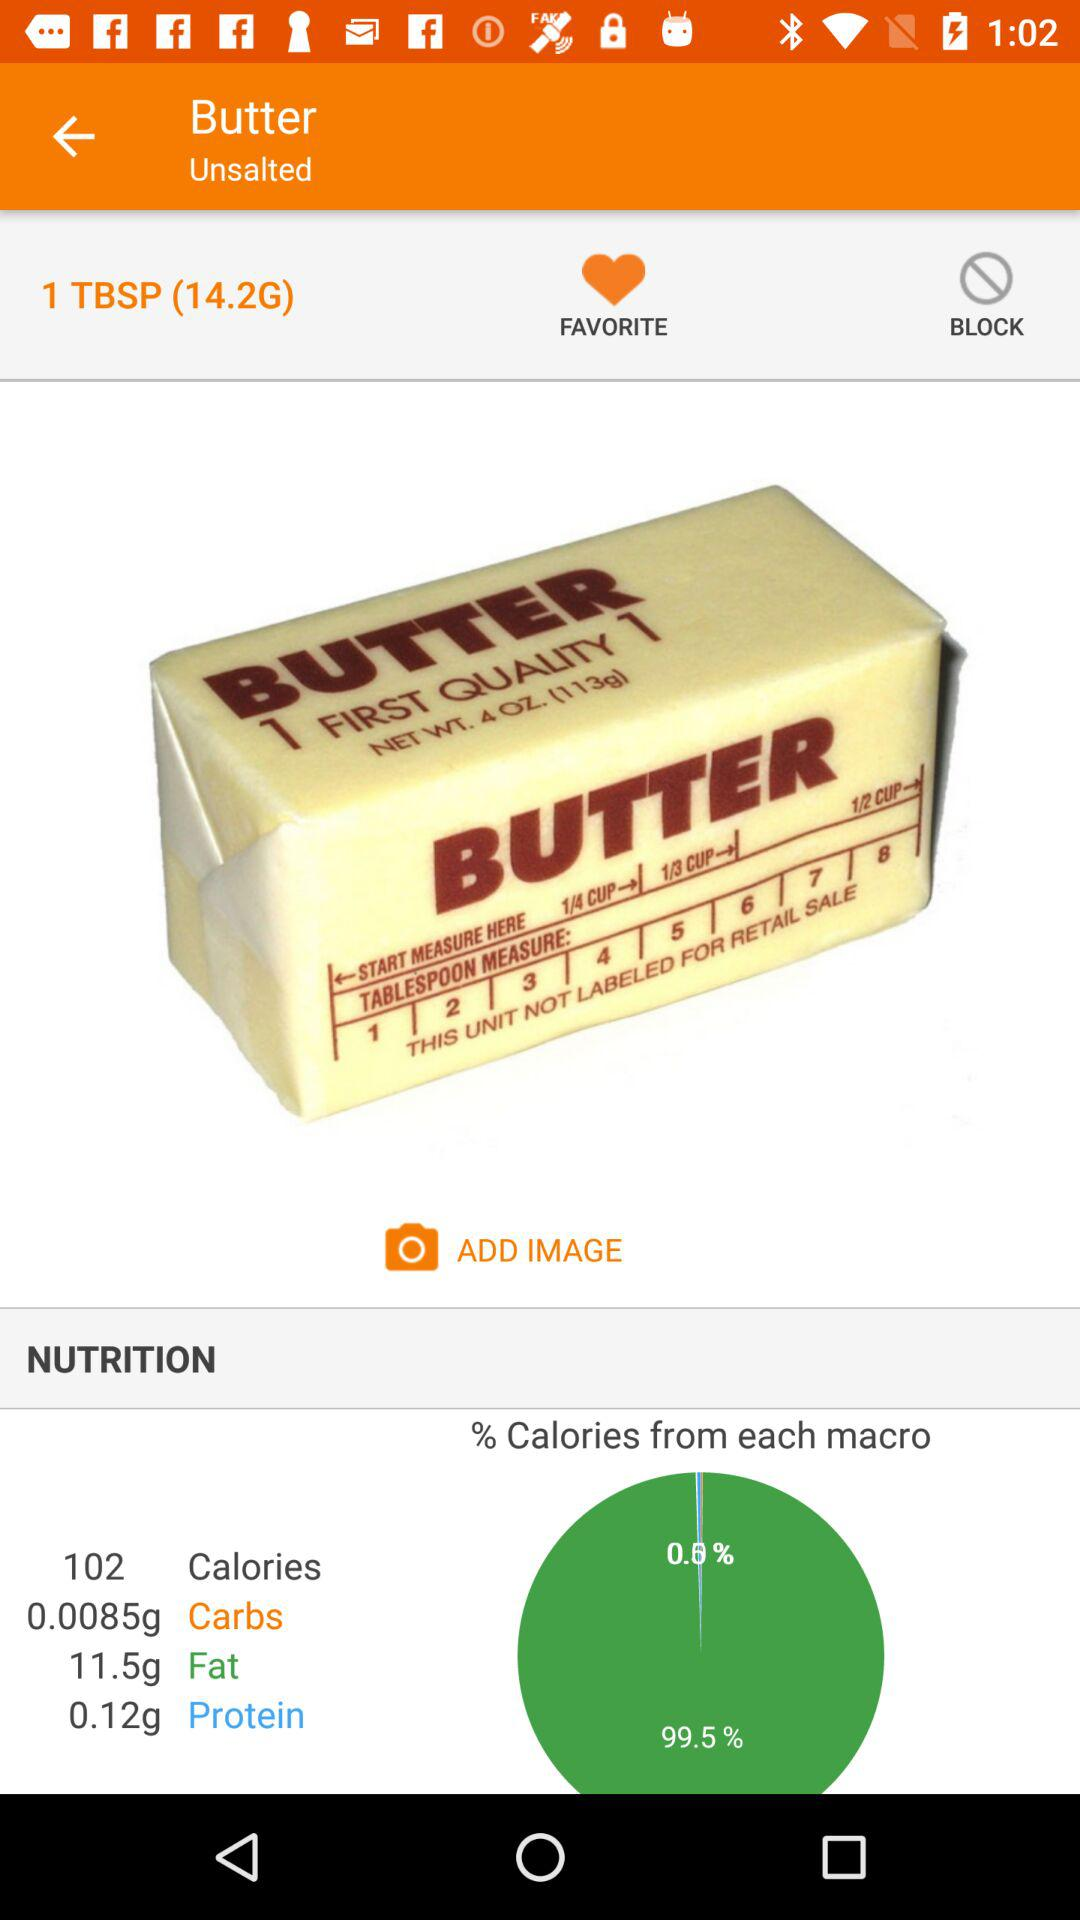How much fat is there in butter? There is 11.5g of fat in butter. 